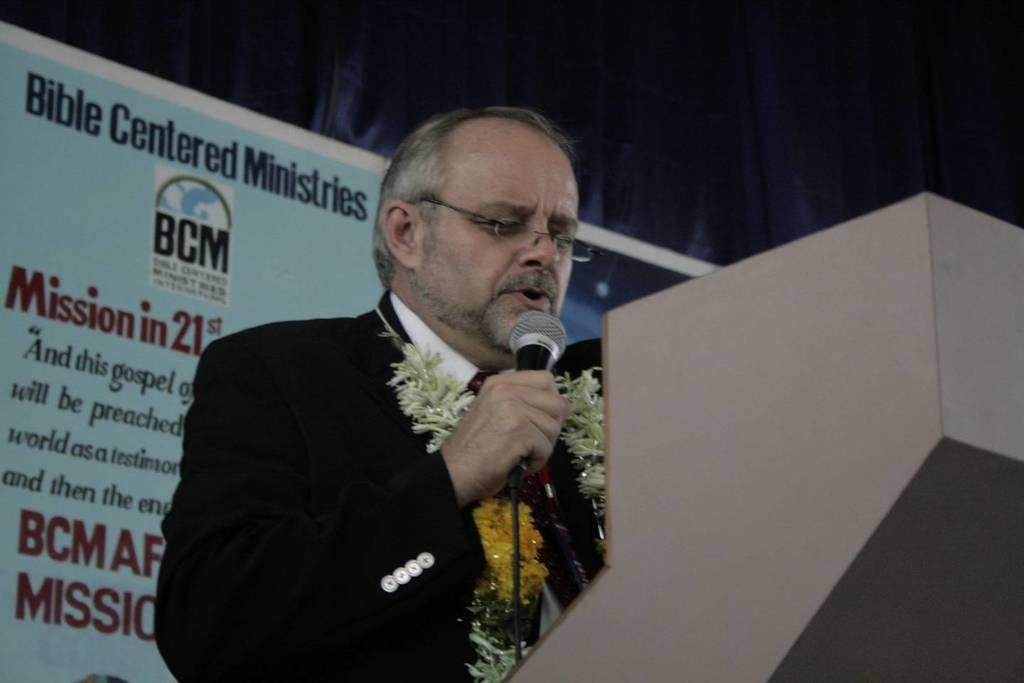What is the man in the image doing? The man is talking on a microphone. What can be seen on the man's face in the image? The man is wearing spectacles. What is the man standing behind in the image? There is a podium in the image. What is visible in the background of the image? There is a banner and cloth visible in the background. How many spiders are crawling on the microphone in the image? There are no spiders visible in the image; the man is talking on a microphone without any spiders present. 